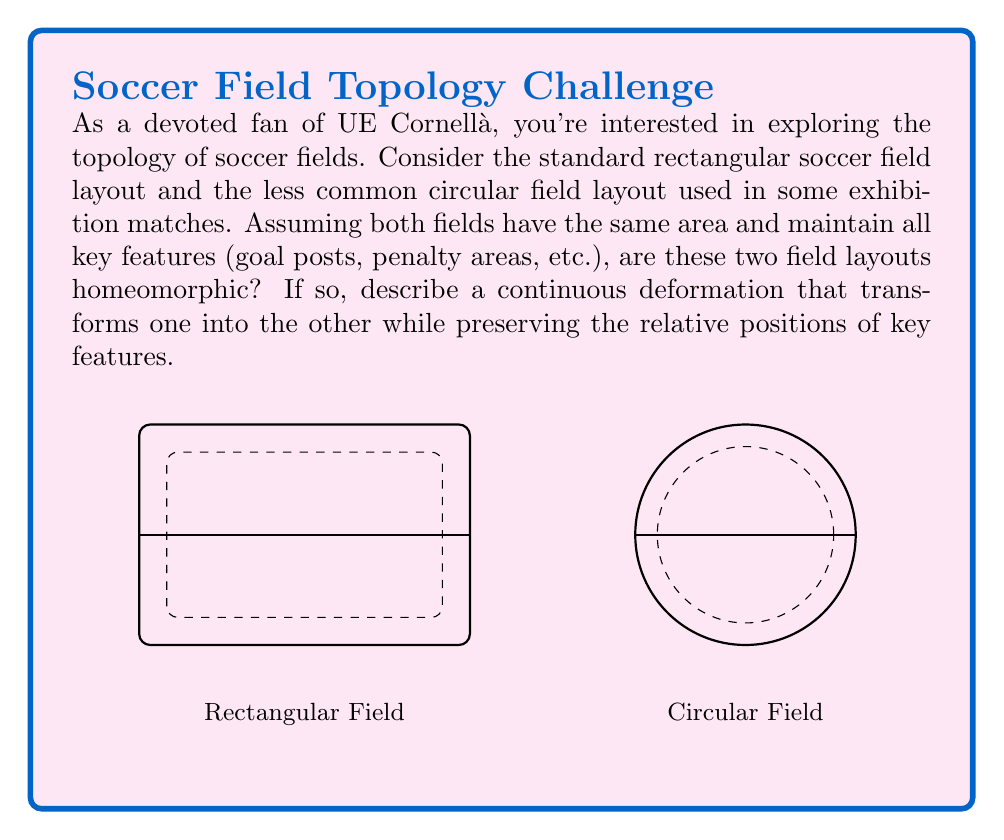Can you answer this question? To determine if the rectangular and circular soccer field layouts are homeomorphic, we need to consider the following steps:

1) Definition of homeomorphism: Two topological spaces are homeomorphic if there exists a continuous bijective function with a continuous inverse that maps one space onto the other.

2) Key properties to preserve:
   - Continuity of the field boundary
   - Relative positions of features (center line, penalty areas, etc.)
   - Connectedness of the field

3) Continuous deformation:
   - Start with the rectangular field
   - Gradually round the corners while maintaining the overall shape
   - Continue to smoothly deform the rounded rectangle into a circle

4) Mathematical representation:
   Let $f: [0,1] \times \mathbb{R}^2 \to \mathbb{R}^2$ be a continuous function where:
   $$f(0,x,y) = (x,y)$$ (rectangular field)
   $$f(1,x,y) = (\sqrt{x^2+y^2}\cos(\theta), \sqrt{x^2+y^2}\sin(\theta))$$ (circular field)
   where $\theta = \arctan2(y,x)$

5) Preservation of key features:
   - The boundary remains continuous throughout the transformation
   - The center line deforms but maintains its position dividing the field
   - Penalty areas and other features deform but keep their relative positions

6) Bijectivity and continuity:
   - The function $f$ is bijective for each $t \in [0,1]$
   - Both $f$ and its inverse are continuous

Therefore, the rectangular and circular field layouts are indeed homeomorphic, as we can construct a continuous deformation that preserves the topological properties of the field.
Answer: Yes, homeomorphic. 